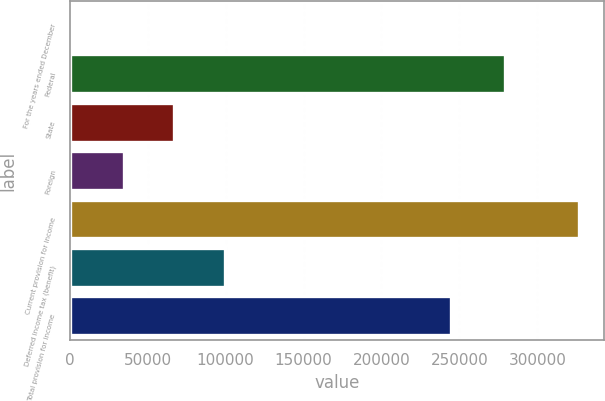Convert chart. <chart><loc_0><loc_0><loc_500><loc_500><bar_chart><fcel>For the years ended December<fcel>Federal<fcel>State<fcel>Foreign<fcel>Current provision for income<fcel>Deferred income tax (benefit)<fcel>Total provision for income<nl><fcel>2004<fcel>279127<fcel>66942.4<fcel>34473.2<fcel>326696<fcel>99411.6<fcel>244765<nl></chart> 